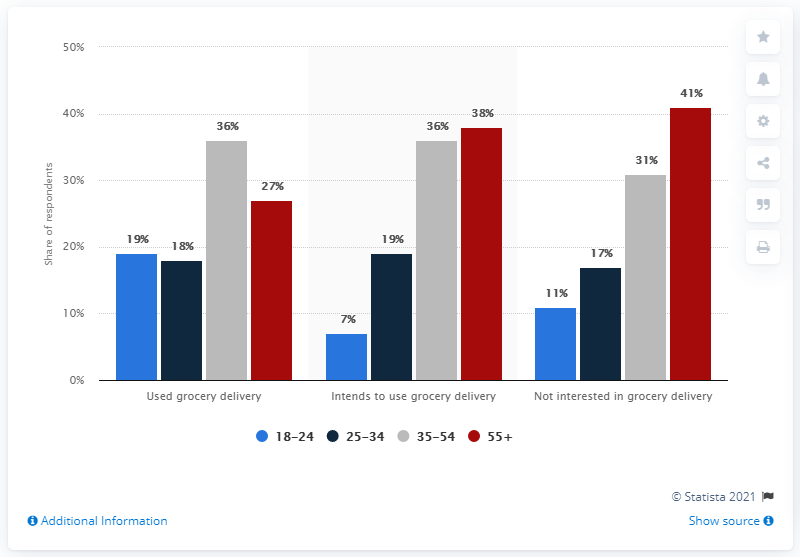Draw attention to some important aspects in this diagram. The ratio of those who intend to use grocery delivery to those who have actually used it among individuals aged 35-54 is 1:1. It is my belief that the age category of 18-24 has the least value. 